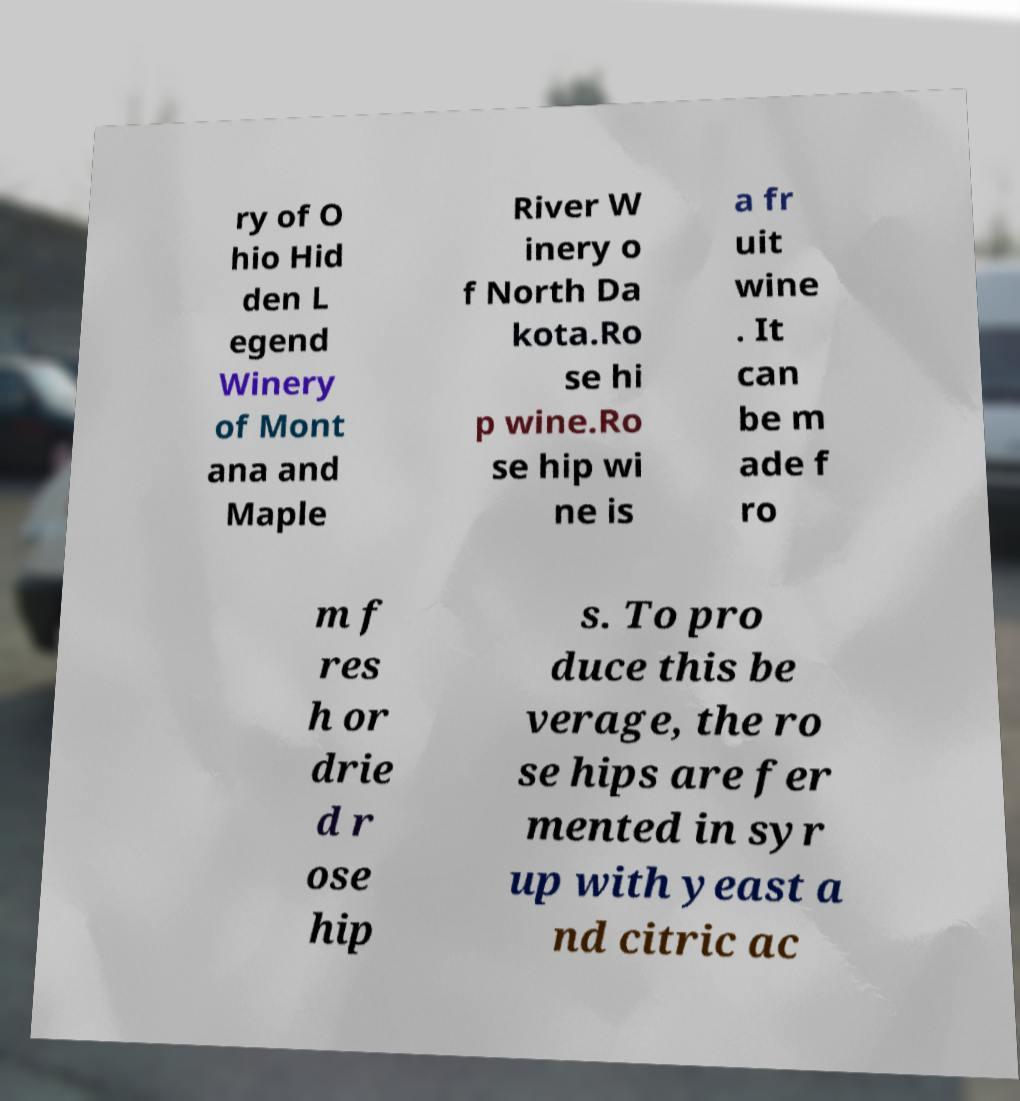I need the written content from this picture converted into text. Can you do that? ry of O hio Hid den L egend Winery of Mont ana and Maple River W inery o f North Da kota.Ro se hi p wine.Ro se hip wi ne is a fr uit wine . It can be m ade f ro m f res h or drie d r ose hip s. To pro duce this be verage, the ro se hips are fer mented in syr up with yeast a nd citric ac 